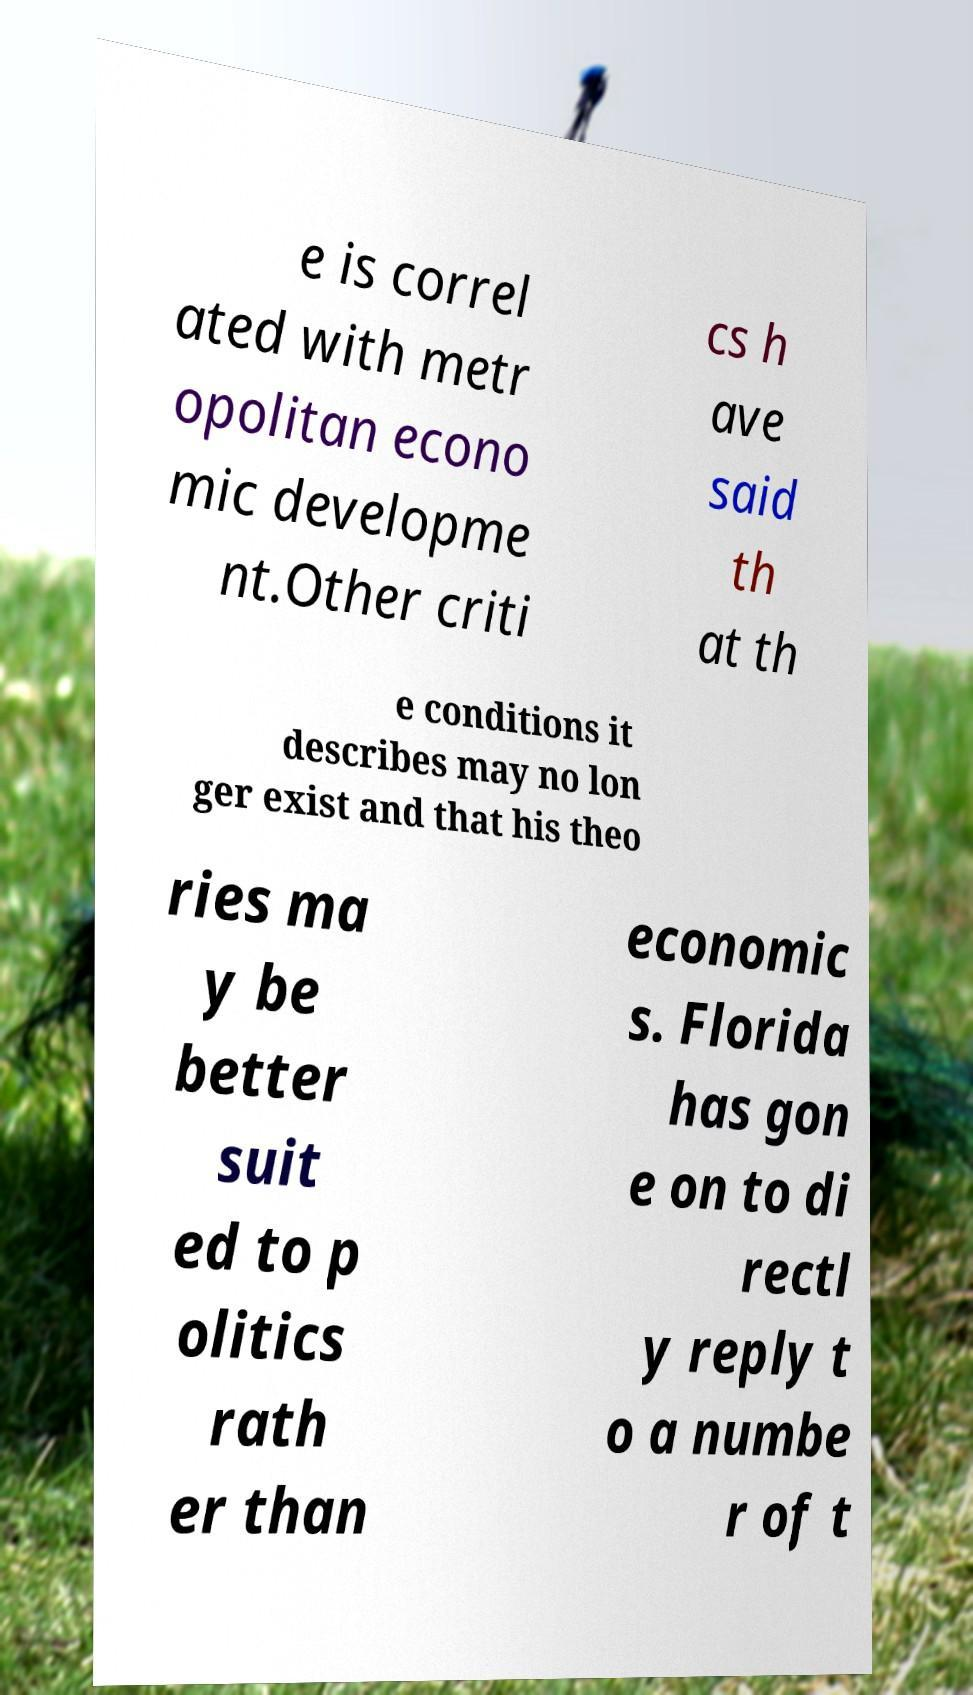Can you read and provide the text displayed in the image?This photo seems to have some interesting text. Can you extract and type it out for me? e is correl ated with metr opolitan econo mic developme nt.Other criti cs h ave said th at th e conditions it describes may no lon ger exist and that his theo ries ma y be better suit ed to p olitics rath er than economic s. Florida has gon e on to di rectl y reply t o a numbe r of t 